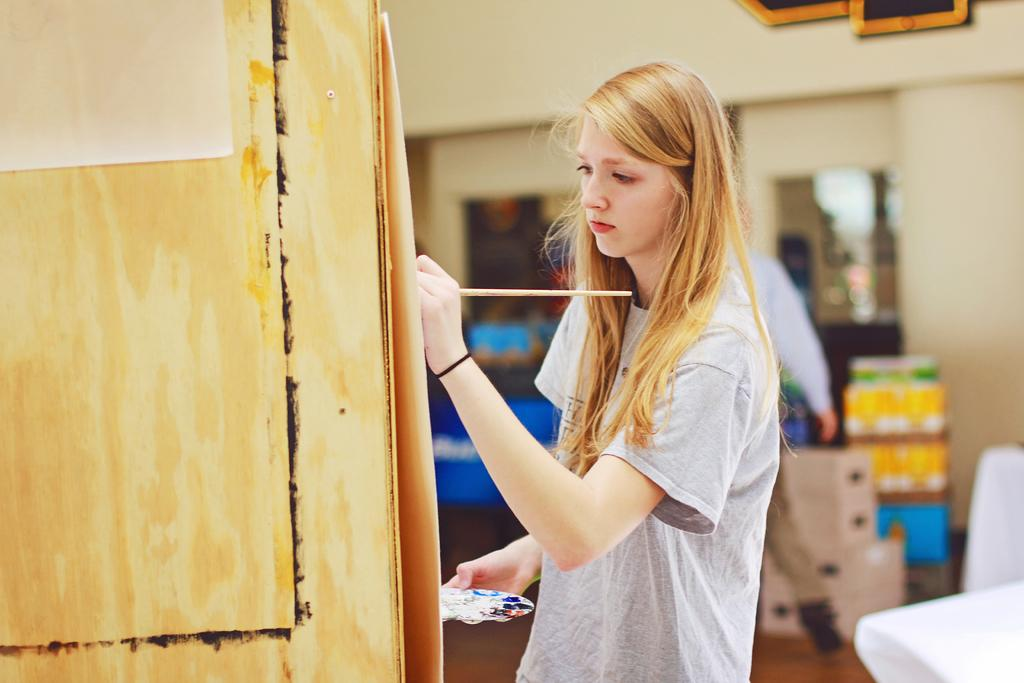What is the woman in the image holding? The woman is holding a paint brush and a painting plate. What might the woman be doing in the image? The woman might be painting, given that she is holding a paint brush and a painting plate. Can you describe the other person in the image? There is a person standing in the image, but no specific details about them are provided. What other objects can be seen in the image? There are papers, boxes, and other items in the image. What type of leather is being used to make a decision in the image? There is no leather or decision-making process depicted in the image. 